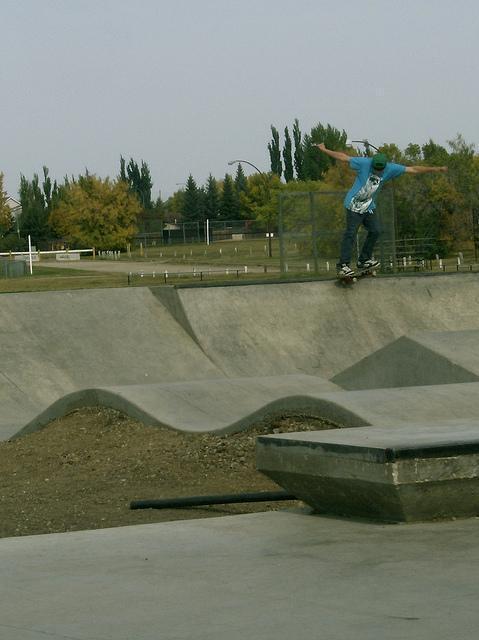How many people total can you see?
Give a very brief answer. 1. How many kites are there?
Give a very brief answer. 0. 